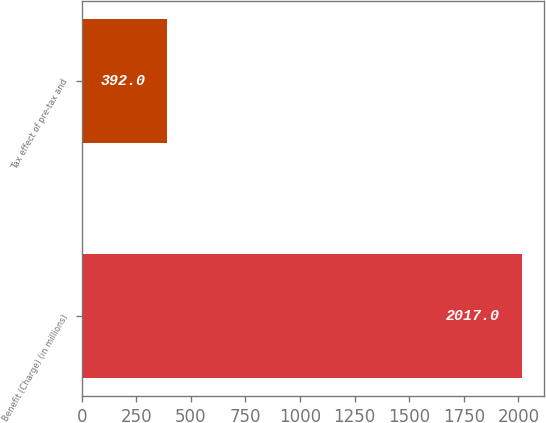Convert chart. <chart><loc_0><loc_0><loc_500><loc_500><bar_chart><fcel>Benefit (Charge) (in millions)<fcel>Tax effect of pre-tax and<nl><fcel>2017<fcel>392<nl></chart> 